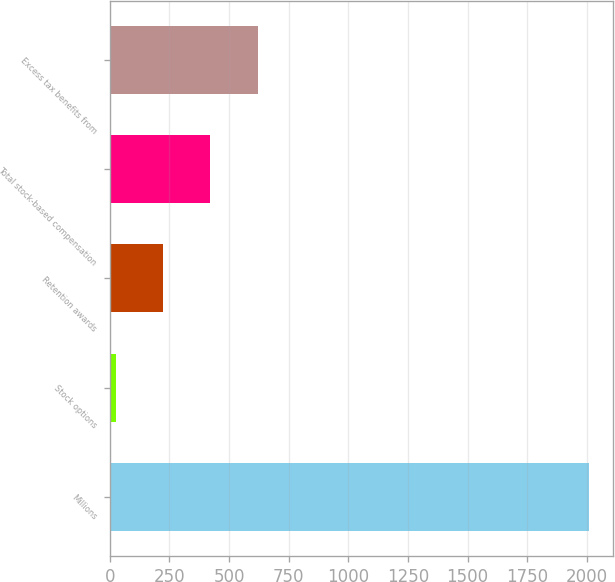Convert chart to OTSL. <chart><loc_0><loc_0><loc_500><loc_500><bar_chart><fcel>Millions<fcel>Stock options<fcel>Retention awards<fcel>Total stock-based compensation<fcel>Excess tax benefits from<nl><fcel>2008<fcel>25<fcel>223.3<fcel>421.6<fcel>619.9<nl></chart> 